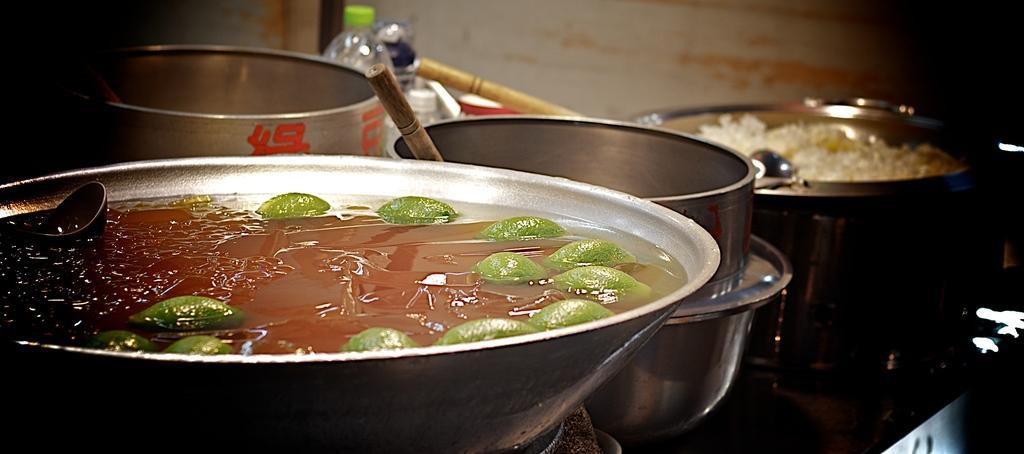Please provide a concise description of this image. This image is taken indoors. In the background there is a wall. At the bottom of the image there is a table with a few vessels, a few bottles, a bowl with soup and lemon slices and a vessel with a food item on it. 